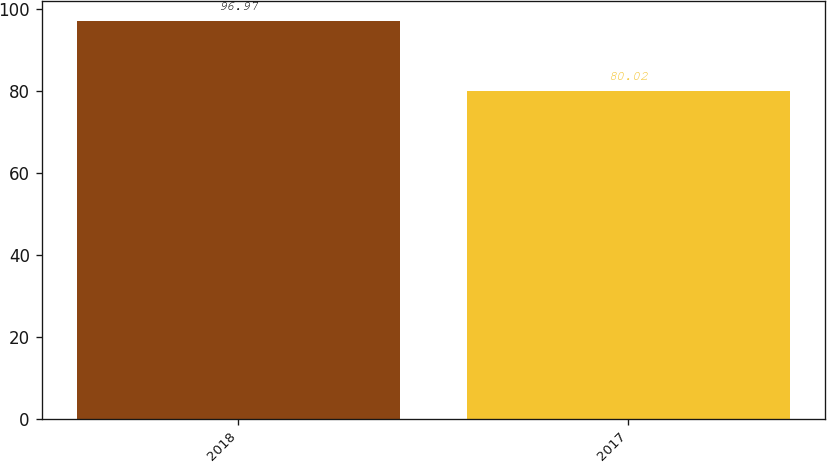Convert chart to OTSL. <chart><loc_0><loc_0><loc_500><loc_500><bar_chart><fcel>2018<fcel>2017<nl><fcel>96.97<fcel>80.02<nl></chart> 